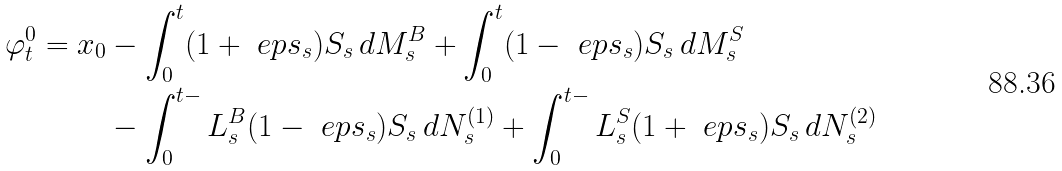<formula> <loc_0><loc_0><loc_500><loc_500>\varphi ^ { 0 } _ { t } = x _ { 0 } & - \int _ { 0 } ^ { t } ( 1 + \ e p s _ { s } ) S _ { s } \, d M ^ { B } _ { s } + \int _ { 0 } ^ { t } ( 1 - \ e p s _ { s } ) S _ { s } \, d M ^ { S } _ { s } \\ & - \int _ { 0 } ^ { t - } L ^ { B } _ { s } ( 1 - \ e p s _ { s } ) S _ { s } \, d N ^ { ( 1 ) } _ { s } + \int _ { 0 } ^ { t - } L ^ { S } _ { s } ( 1 + \ e p s _ { s } ) S _ { s } \, d N ^ { ( 2 ) } _ { s }</formula> 